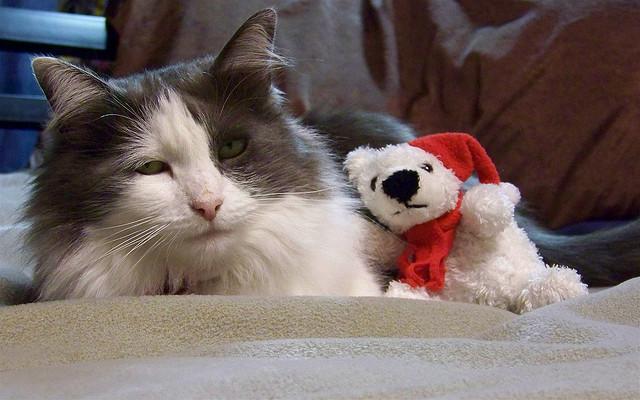What animals are these?
Be succinct. Cat. IS the cat a short hair or long hair?
Give a very brief answer. Long. What is beside the cat?
Keep it brief. Stuffed bear. What color are this cat's eyes?
Give a very brief answer. Green. What color is the object on the left wearing?
Give a very brief answer. Red. What is the cat holding?
Write a very short answer. Bear. 